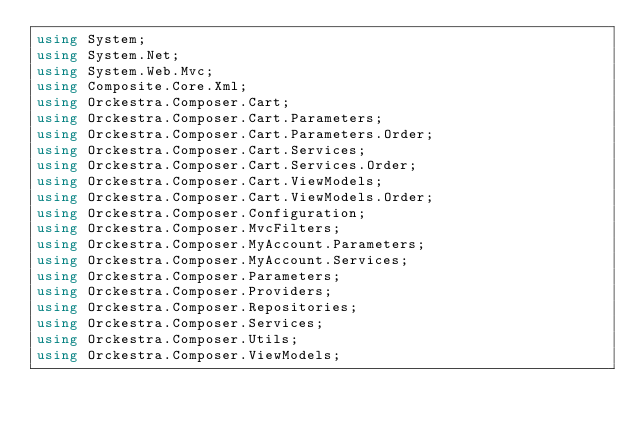Convert code to text. <code><loc_0><loc_0><loc_500><loc_500><_C#_>using System;
using System.Net;
using System.Web.Mvc;
using Composite.Core.Xml;
using Orckestra.Composer.Cart;
using Orckestra.Composer.Cart.Parameters;
using Orckestra.Composer.Cart.Parameters.Order;
using Orckestra.Composer.Cart.Services;
using Orckestra.Composer.Cart.Services.Order;
using Orckestra.Composer.Cart.ViewModels;
using Orckestra.Composer.Cart.ViewModels.Order;
using Orckestra.Composer.Configuration;
using Orckestra.Composer.MvcFilters;
using Orckestra.Composer.MyAccount.Parameters;
using Orckestra.Composer.MyAccount.Services;
using Orckestra.Composer.Parameters;
using Orckestra.Composer.Providers;
using Orckestra.Composer.Repositories;
using Orckestra.Composer.Services;
using Orckestra.Composer.Utils;
using Orckestra.Composer.ViewModels;
</code> 